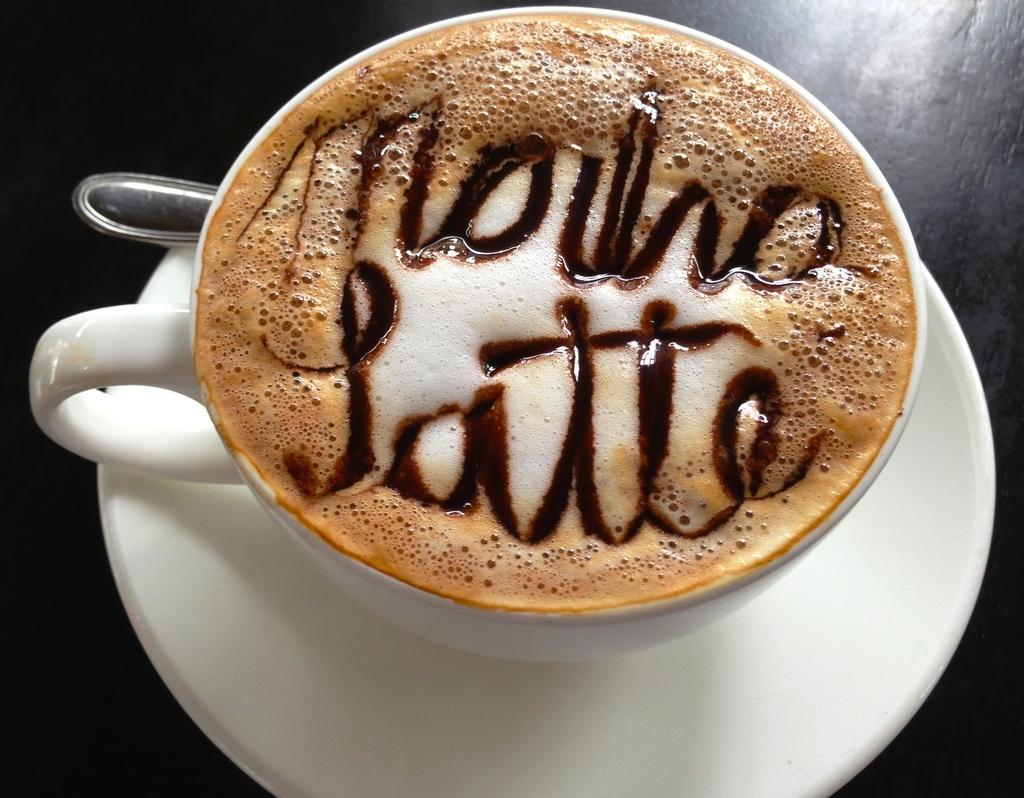What type of cup is in the image? There is a white cup in the image. Is there anything accompanying the cup? Yes, there is a saucer associated with the cup. What is inside the cup? There is coffee latte in the cup. What utensil is present in the image? There is a spoon in the image. Can you describe the coffee latte further? There is text visible on the coffee latte. How many robins are perched on the spoon in the image? There are no robins present in the image; it features a white cup, saucer, coffee latte, and a spoon. 